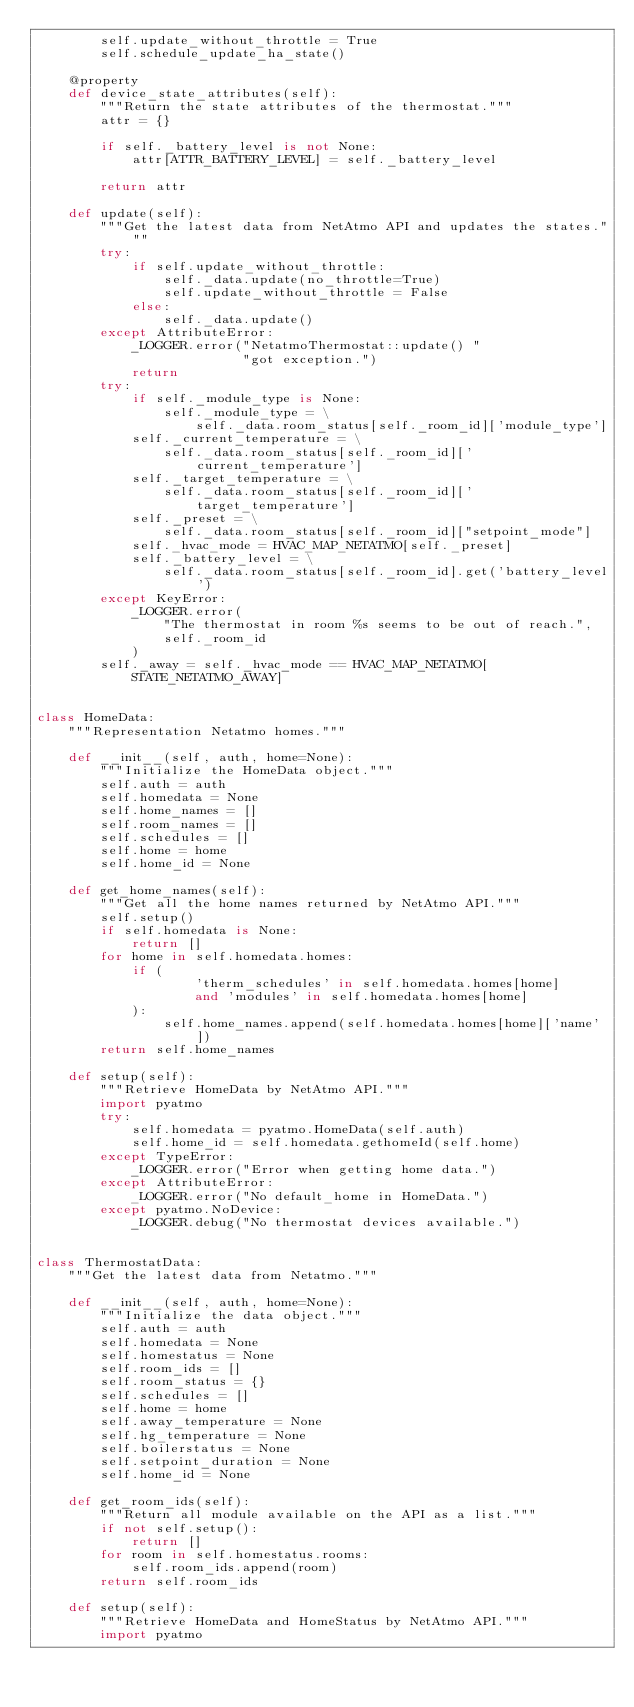Convert code to text. <code><loc_0><loc_0><loc_500><loc_500><_Python_>        self.update_without_throttle = True
        self.schedule_update_ha_state()

    @property
    def device_state_attributes(self):
        """Return the state attributes of the thermostat."""
        attr = {}

        if self._battery_level is not None:
            attr[ATTR_BATTERY_LEVEL] = self._battery_level

        return attr

    def update(self):
        """Get the latest data from NetAtmo API and updates the states."""
        try:
            if self.update_without_throttle:
                self._data.update(no_throttle=True)
                self.update_without_throttle = False
            else:
                self._data.update()
        except AttributeError:
            _LOGGER.error("NetatmoThermostat::update() "
                          "got exception.")
            return
        try:
            if self._module_type is None:
                self._module_type = \
                    self._data.room_status[self._room_id]['module_type']
            self._current_temperature = \
                self._data.room_status[self._room_id]['current_temperature']
            self._target_temperature = \
                self._data.room_status[self._room_id]['target_temperature']
            self._preset = \
                self._data.room_status[self._room_id]["setpoint_mode"]
            self._hvac_mode = HVAC_MAP_NETATMO[self._preset]
            self._battery_level = \
                self._data.room_status[self._room_id].get('battery_level')
        except KeyError:
            _LOGGER.error(
                "The thermostat in room %s seems to be out of reach.",
                self._room_id
            )
        self._away = self._hvac_mode == HVAC_MAP_NETATMO[STATE_NETATMO_AWAY]


class HomeData:
    """Representation Netatmo homes."""

    def __init__(self, auth, home=None):
        """Initialize the HomeData object."""
        self.auth = auth
        self.homedata = None
        self.home_names = []
        self.room_names = []
        self.schedules = []
        self.home = home
        self.home_id = None

    def get_home_names(self):
        """Get all the home names returned by NetAtmo API."""
        self.setup()
        if self.homedata is None:
            return []
        for home in self.homedata.homes:
            if (
                    'therm_schedules' in self.homedata.homes[home]
                    and 'modules' in self.homedata.homes[home]
            ):
                self.home_names.append(self.homedata.homes[home]['name'])
        return self.home_names

    def setup(self):
        """Retrieve HomeData by NetAtmo API."""
        import pyatmo
        try:
            self.homedata = pyatmo.HomeData(self.auth)
            self.home_id = self.homedata.gethomeId(self.home)
        except TypeError:
            _LOGGER.error("Error when getting home data.")
        except AttributeError:
            _LOGGER.error("No default_home in HomeData.")
        except pyatmo.NoDevice:
            _LOGGER.debug("No thermostat devices available.")


class ThermostatData:
    """Get the latest data from Netatmo."""

    def __init__(self, auth, home=None):
        """Initialize the data object."""
        self.auth = auth
        self.homedata = None
        self.homestatus = None
        self.room_ids = []
        self.room_status = {}
        self.schedules = []
        self.home = home
        self.away_temperature = None
        self.hg_temperature = None
        self.boilerstatus = None
        self.setpoint_duration = None
        self.home_id = None

    def get_room_ids(self):
        """Return all module available on the API as a list."""
        if not self.setup():
            return []
        for room in self.homestatus.rooms:
            self.room_ids.append(room)
        return self.room_ids

    def setup(self):
        """Retrieve HomeData and HomeStatus by NetAtmo API."""
        import pyatmo</code> 